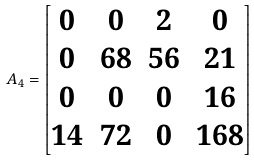<formula> <loc_0><loc_0><loc_500><loc_500>A _ { 4 } = \begin{bmatrix} 0 & 0 & 2 & 0 \\ 0 & 6 8 & 5 6 & 2 1 \\ 0 & 0 & 0 & 1 6 \\ 1 4 & 7 2 & 0 & 1 6 8 \\ \end{bmatrix}</formula> 